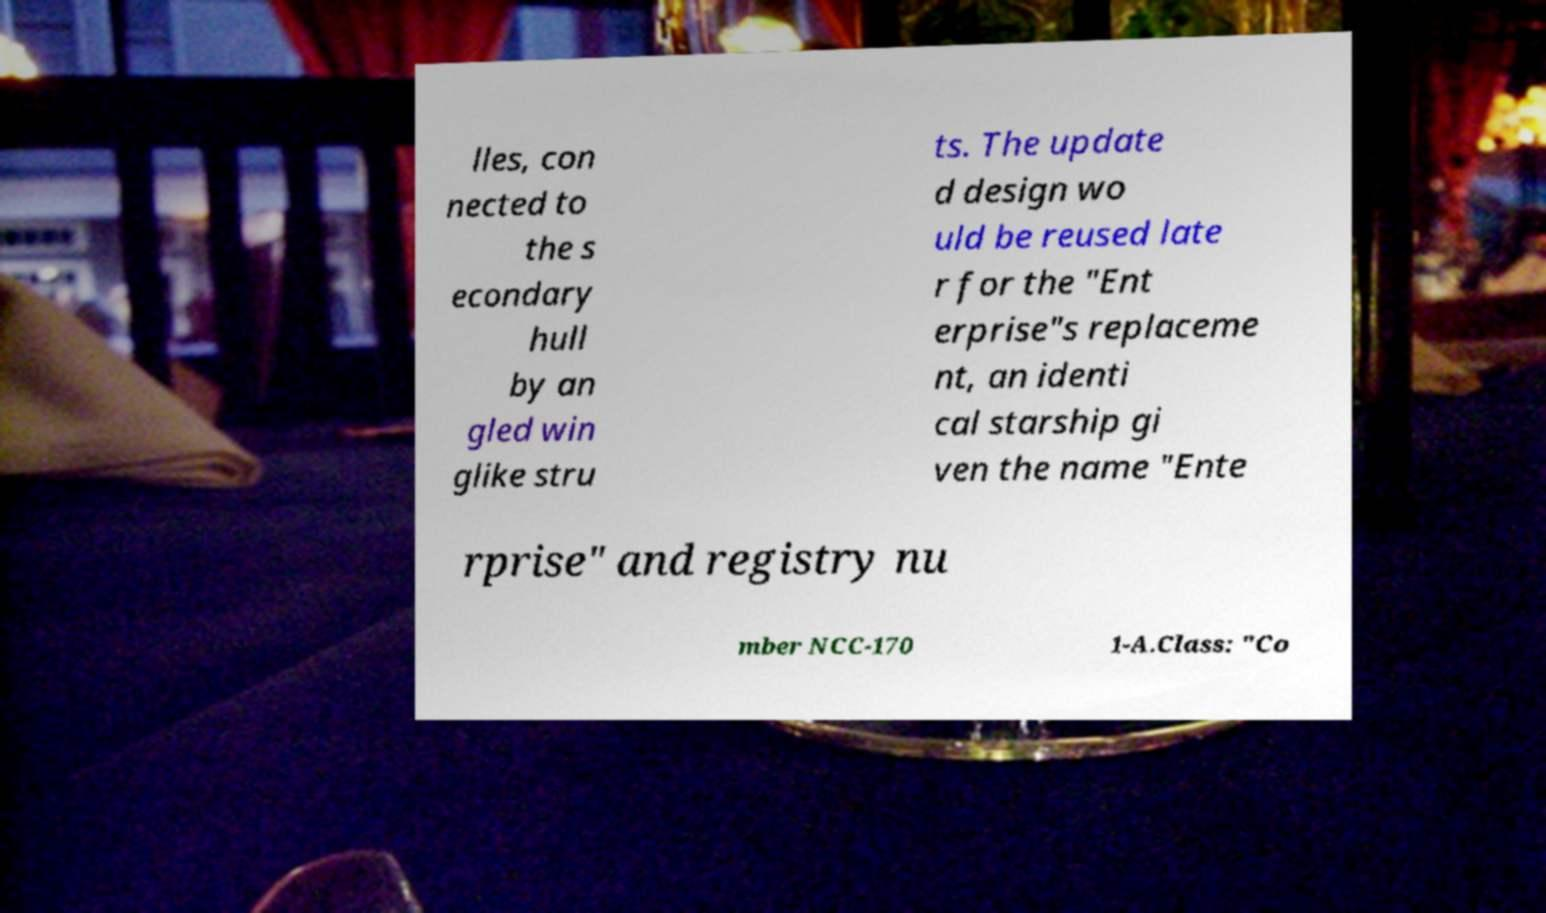Please read and relay the text visible in this image. What does it say? lles, con nected to the s econdary hull by an gled win glike stru ts. The update d design wo uld be reused late r for the "Ent erprise"s replaceme nt, an identi cal starship gi ven the name "Ente rprise" and registry nu mber NCC-170 1-A.Class: "Co 